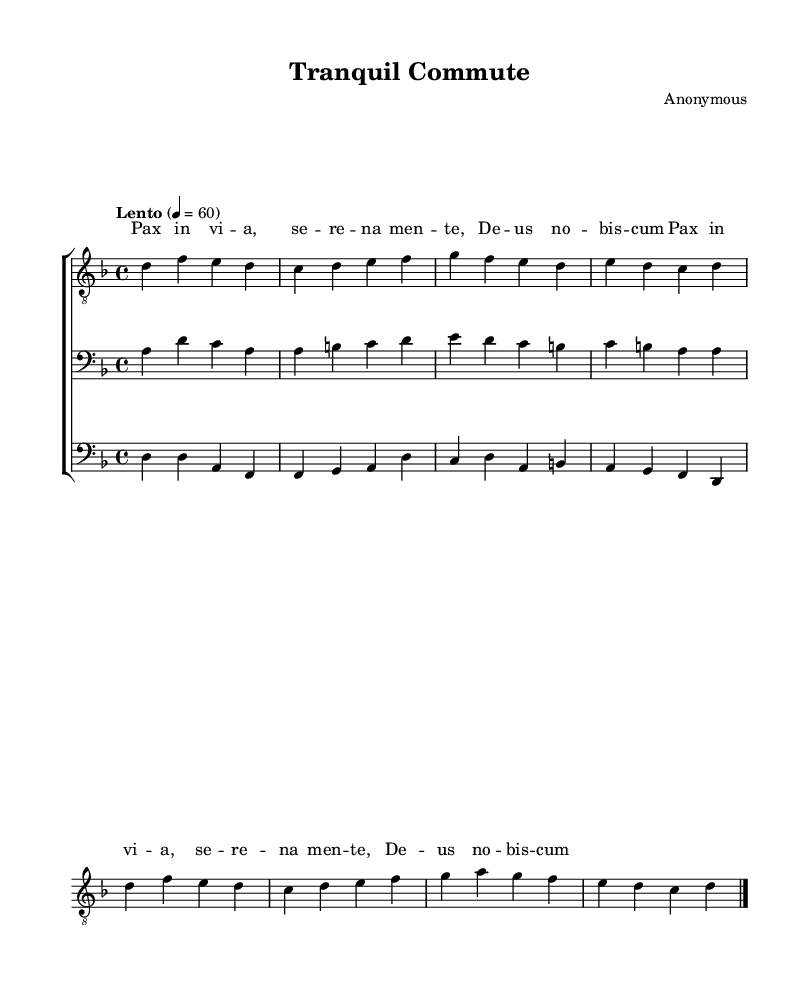What is the key signature of this music? The key signature is indicated by the symbols at the beginning of the staff. In this case, it is D minor, which has one flat (B flat).
Answer: D minor What is the time signature used in this score? The time signature is found at the beginning of the music, where the two numbers are displayed. Here, it shows 4 over 4, meaning there are four beats per measure.
Answer: 4/4 What is the tempo marking of the piece? The tempo is indicated by the word "Lento" at the beginning and is accompanied by a metronome marking of 60, which specifies the speed of the music.
Answer: Lento How many vocal parts are indicated in the score? By examining the score, we can see that there are three specific vocal staffs labeled tenor, baritone, and bass. Therefore, there are a total of three vocal parts.
Answer: Three What is the primary lyrical content of the piece? The lyrics are placed beneath the tenor part and repeat the phrase "Pax in via, serenamente, Deus nobis cum," which is indicative of the piece's meditative theme.
Answer: Pax in via, serenamente, Deus nobis cum Which clef is used for the tenor voice? The clef symbol displayed at the beginning of the tenor staff indicates that it uses the treble clef.
Answer: Treble clef What is the final note of the tenor music? By looking at the tenor music, the last note indicated before the bar line is a D note, which concludes the melody.
Answer: D 